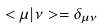<formula> <loc_0><loc_0><loc_500><loc_500>< \mu | \nu > = \delta _ { \mu \nu }</formula> 